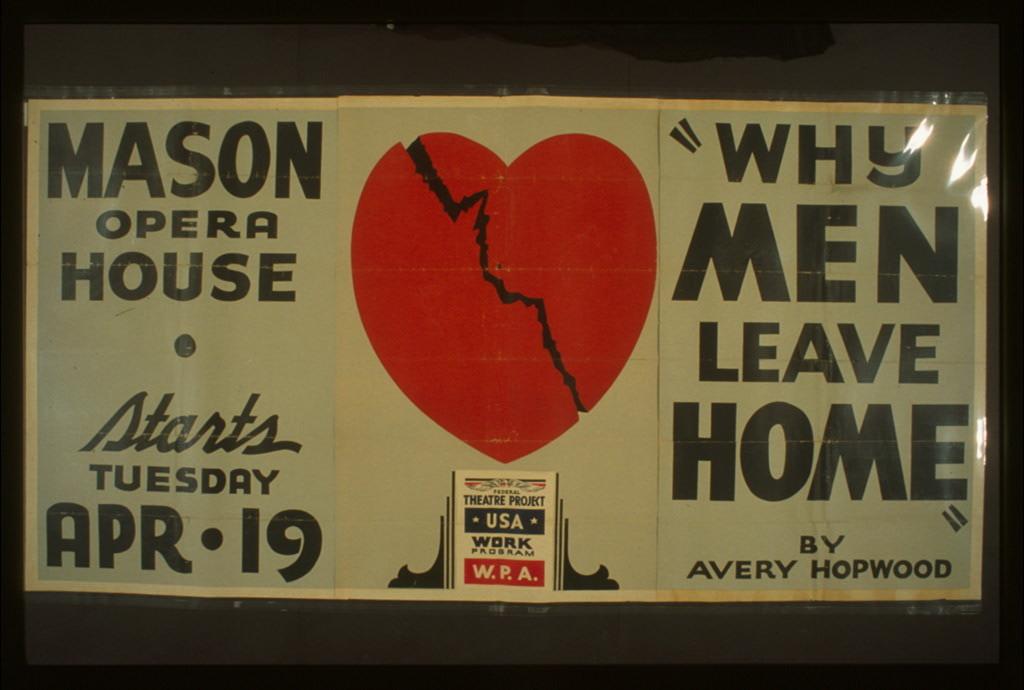What opera house is this?
Provide a succinct answer. Mason. What date is on the sign?
Keep it short and to the point. April 19. 